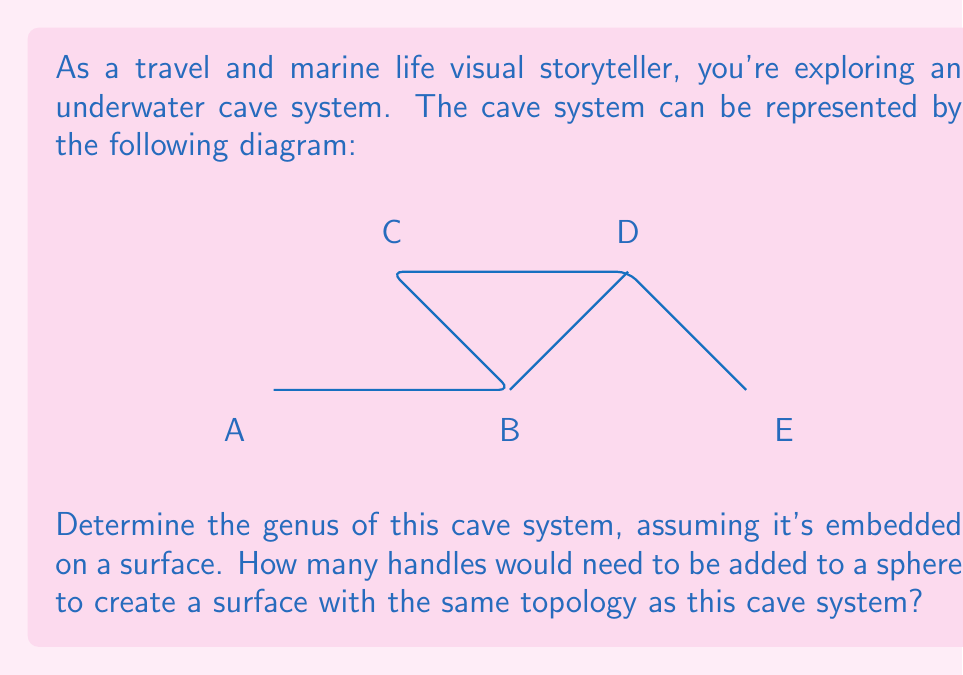Provide a solution to this math problem. To determine the genus of the cave system, we need to follow these steps:

1. Count the number of vertices (V), edges (E), and faces (F) in the diagram:
   V = 5 (A, B, C, D, E)
   E = 5 (AB, BC, CD, DE, BD)
   F = 2 (ABC, BDE)

2. Calculate the Euler characteristic (χ) using the formula:
   $$χ = V - E + F$$
   $$χ = 5 - 5 + 2 = 2$$

3. For a closed orientable surface, the relationship between the Euler characteristic and genus (g) is given by:
   $$χ = 2 - 2g$$

4. Solve for g:
   $$2 = 2 - 2g$$
   $$2g = 0$$
   $$g = 0$$

5. The genus being 0 indicates that the surface has the same topology as a sphere.

Therefore, no handles need to be added to a sphere to create a surface with the same topology as this cave system. The cave system can be embedded on the surface of a sphere without any additional handles.
Answer: Genus = 0; No handles needed 